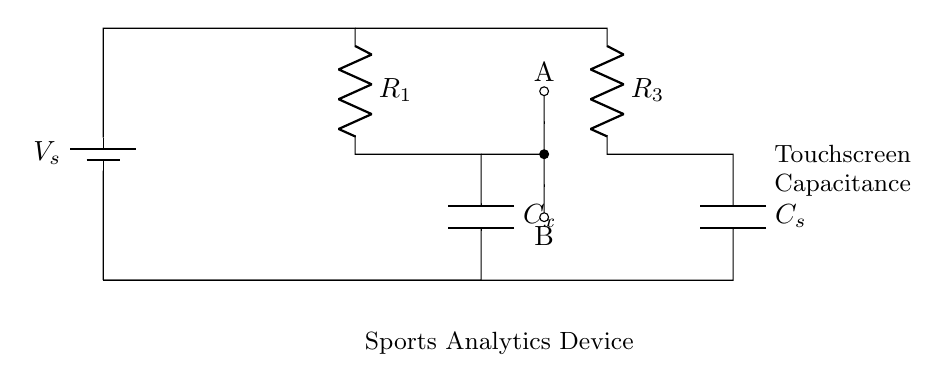What is the type of battery used in this circuit? The circuit shows a symbol for a battery, which is indicated as a voltage source and labeled with \( V_s \).
Answer: battery What does \( C_x \) represent in this circuit? \( C_x \) is labeled as a capacitor and is part of the measurement in the capacitance bridge, indicating an unknown capacitance being tested.
Answer: unknown capacitance Which component is labeled with \( R_3 \)? The symbol immediately connected to the upper branch of the circuit labeled with \( R_3 \) is a resistor, meaning it is performing resistance in that part of the circuit.
Answer: resistor What is the purpose of the connection points A and B? Connections A and B are used for measuring the voltage across \( C_x \) to determine the balance in the bridge circuit, indicating they are crucial for the operation of the capacitance bridge.
Answer: measuring points How many capacitors are present in this circuit? The diagram shows one capacitor labeled \( C_x \) and another labeled \( C_s \), indicating there are two capacitors in total.
Answer: two capacitors What does the label at the bottom of the circuit indicate? The label describes the components involved and their function; here, it indicates that the circuit is part of a sports analytics device.
Answer: sports analytics device What kind of circuit is represented here? The arrangement of the resistors and capacitors is characteristic of a bridge circuit used for measuring unknown capacitance by balancing the bridge.
Answer: capacitance bridge circuit 